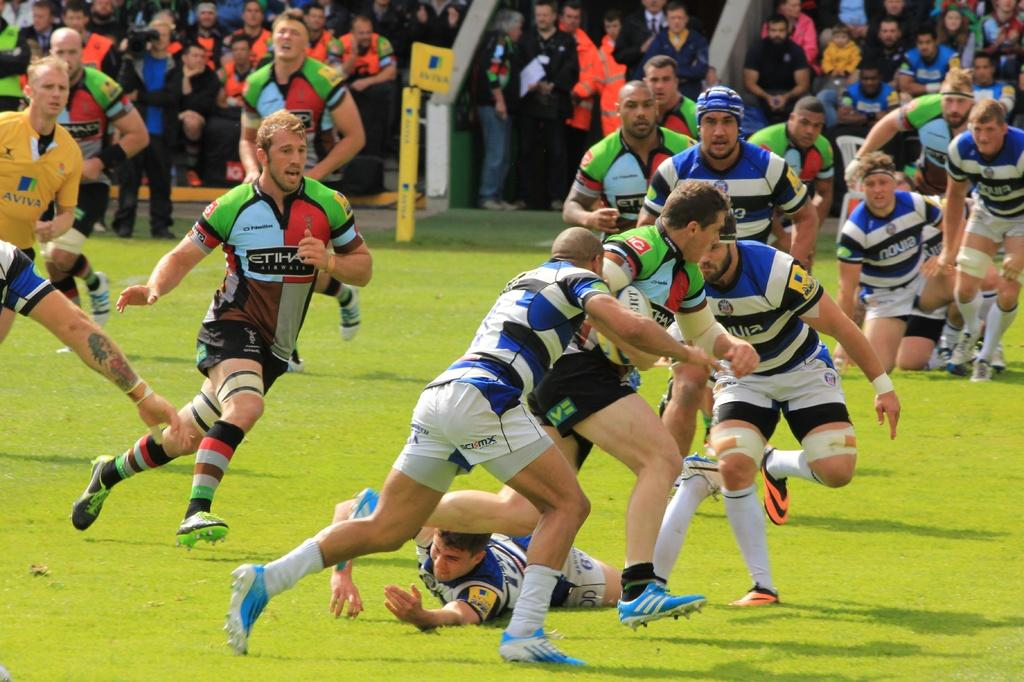Provide a one-sentence caption for the provided image. Soccer players arre going at it, one of them wearing a striped shirt with Novia displayed. 